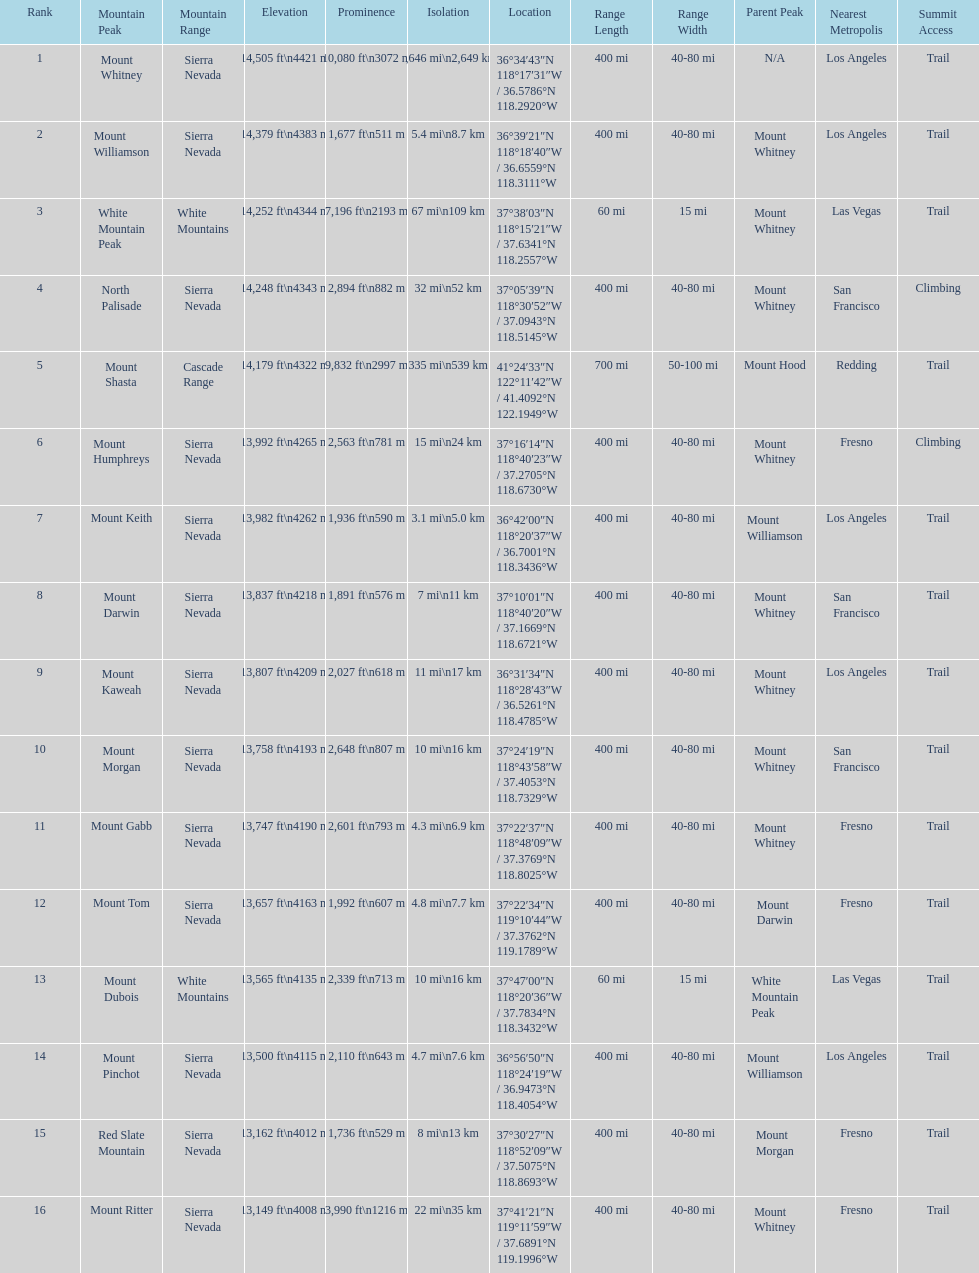Which is taller, mount humphreys or mount kaweah. Mount Humphreys. 